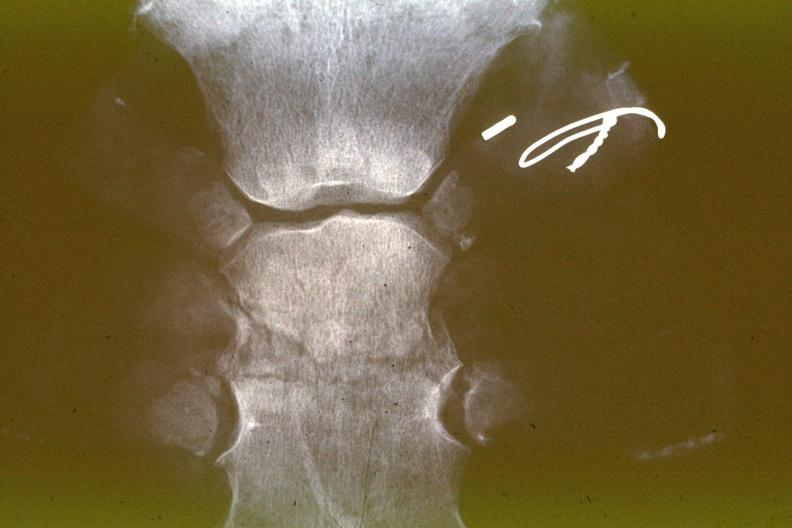s joints present?
Answer the question using a single word or phrase. Yes 